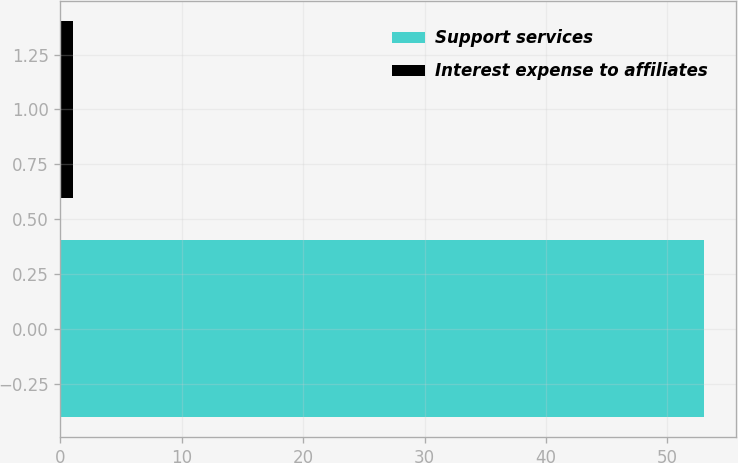Convert chart to OTSL. <chart><loc_0><loc_0><loc_500><loc_500><bar_chart><fcel>Support services<fcel>Interest expense to affiliates<nl><fcel>53<fcel>1<nl></chart> 